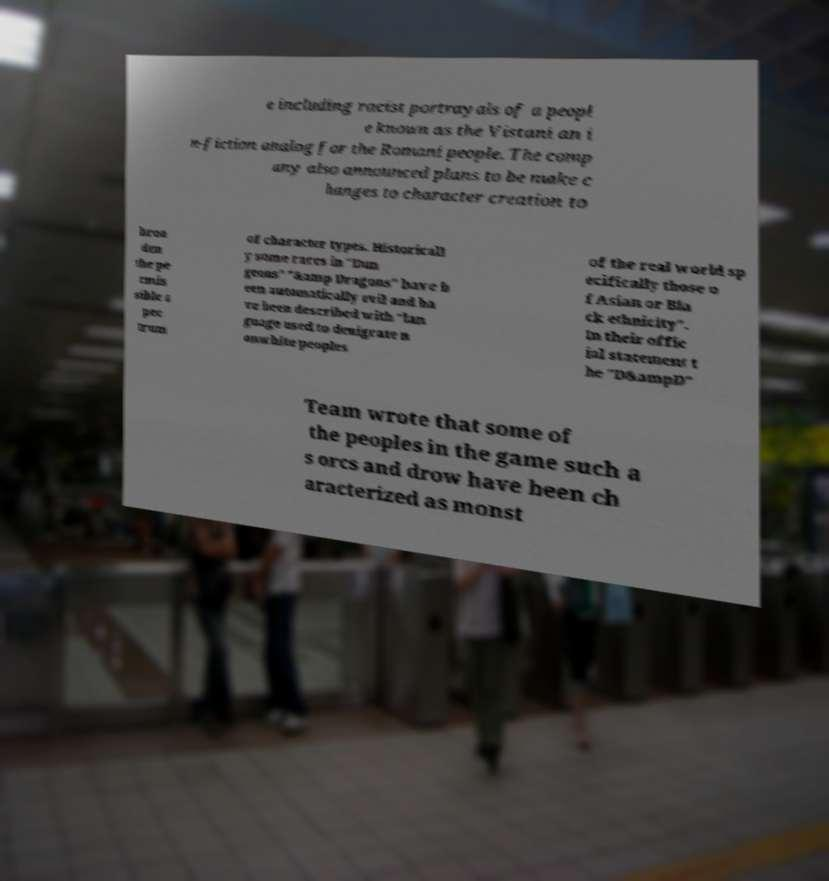What messages or text are displayed in this image? I need them in a readable, typed format. e including racist portrayals of a peopl e known as the Vistani an i n-fiction analog for the Romani people. The comp any also announced plans to be make c hanges to character creation to broa den the pe rmis sible s pec trum of character types. Historicall y some races in "Dun geons" "&amp Dragons" have b een automatically evil and ha ve been described with "lan guage used to denigrate n onwhite peoples of the real world sp ecifically those o f Asian or Bla ck ethnicity". In their offic ial statement t he "D&ampD" Team wrote that some of the peoples in the game such a s orcs and drow have been ch aracterized as monst 